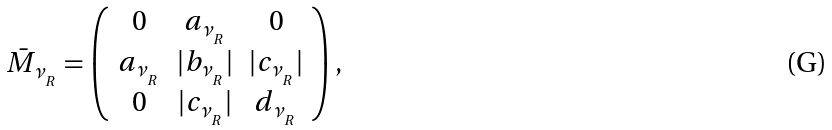Convert formula to latex. <formula><loc_0><loc_0><loc_500><loc_500>\bar { M } _ { \nu _ { _ { R } } } = \left ( \begin{array} { c c c } 0 & a _ { \nu _ { _ { R } } } & 0 \\ a _ { \nu _ { _ { R } } } & | b _ { \nu _ { _ { R } } } | & | c _ { \nu _ { _ { R } } } | \\ 0 & | c _ { \nu _ { _ { R } } } | & d _ { \nu _ { _ { R } } } \end{array} \right ) ,</formula> 